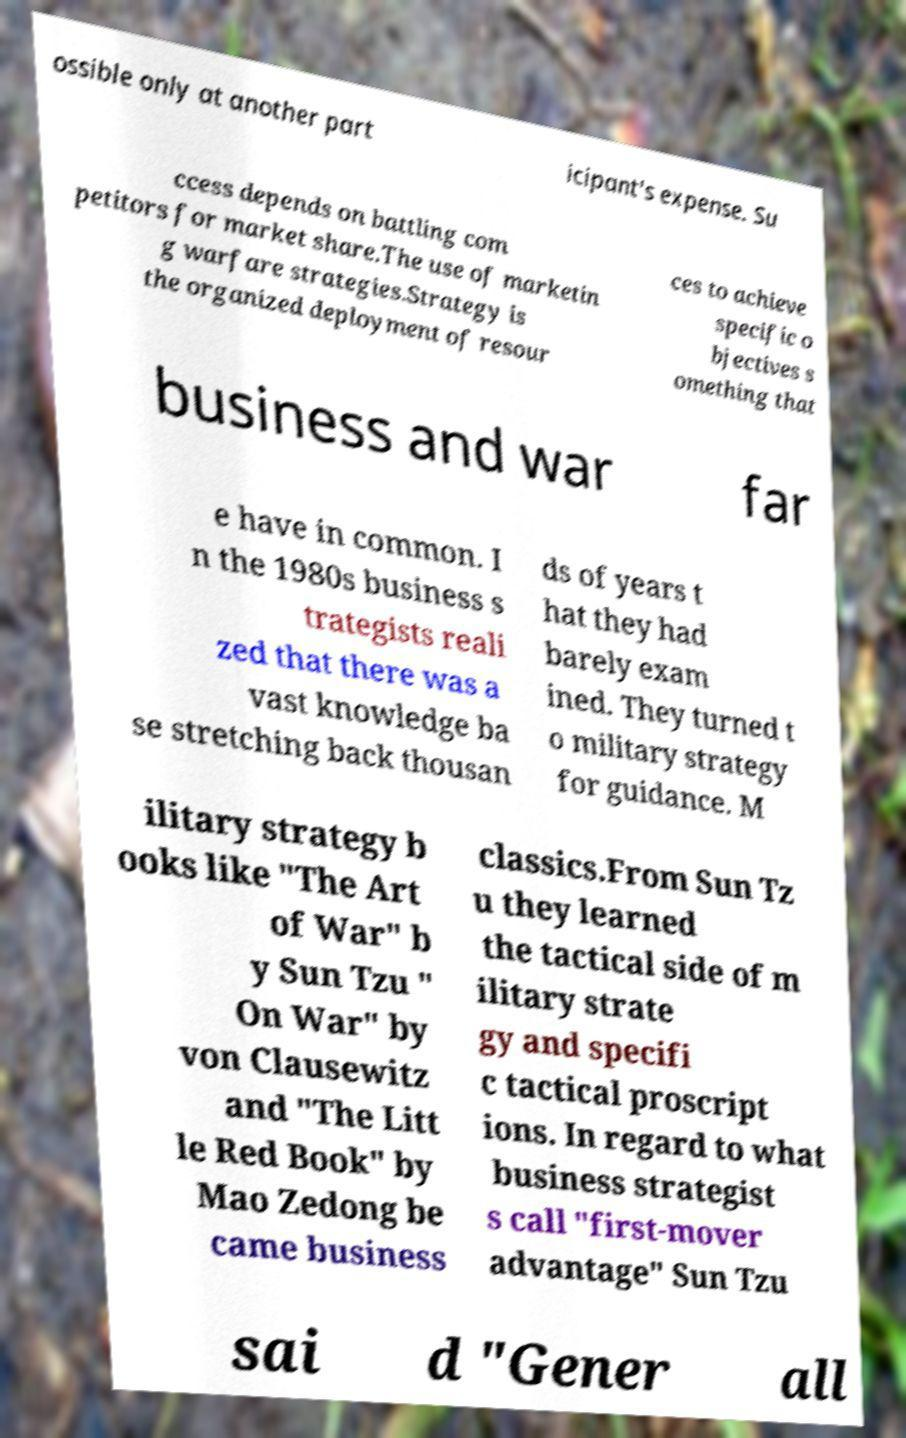Can you accurately transcribe the text from the provided image for me? ossible only at another part icipant's expense. Su ccess depends on battling com petitors for market share.The use of marketin g warfare strategies.Strategy is the organized deployment of resour ces to achieve specific o bjectives s omething that business and war far e have in common. I n the 1980s business s trategists reali zed that there was a vast knowledge ba se stretching back thousan ds of years t hat they had barely exam ined. They turned t o military strategy for guidance. M ilitary strategy b ooks like "The Art of War" b y Sun Tzu " On War" by von Clausewitz and "The Litt le Red Book" by Mao Zedong be came business classics.From Sun Tz u they learned the tactical side of m ilitary strate gy and specifi c tactical proscript ions. In regard to what business strategist s call "first-mover advantage" Sun Tzu sai d "Gener all 